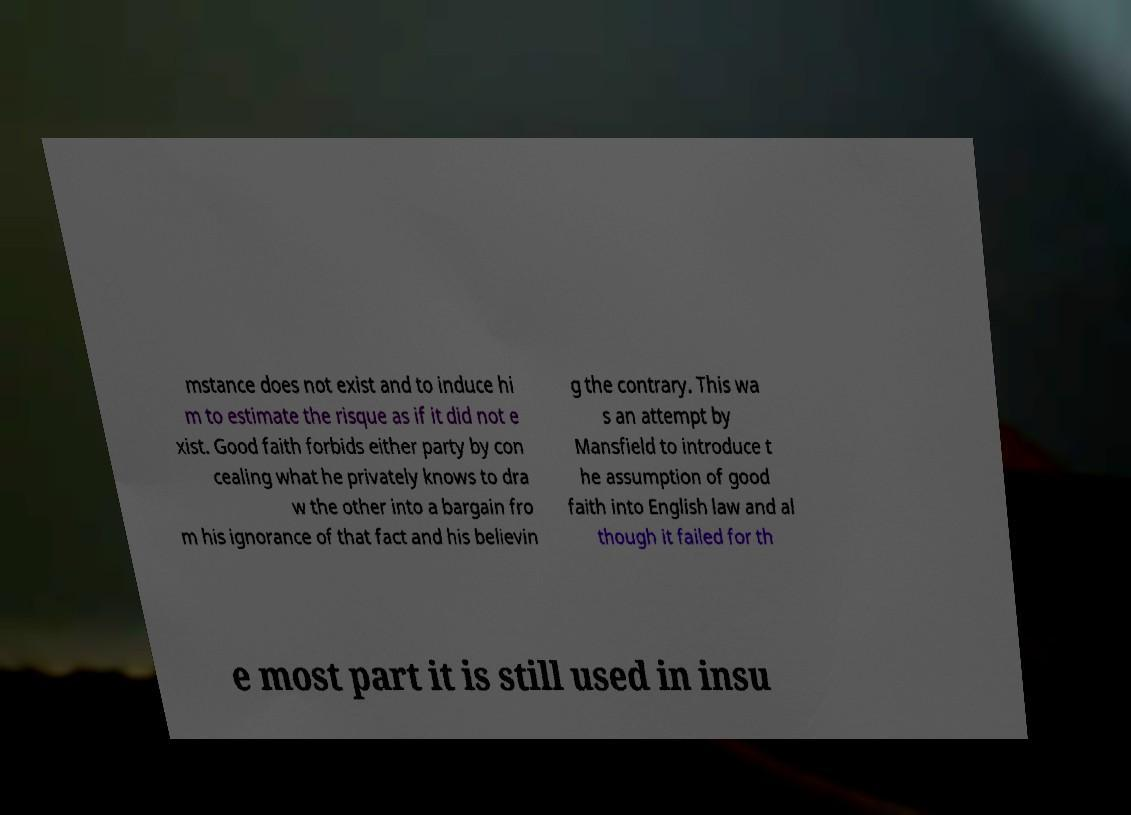I need the written content from this picture converted into text. Can you do that? mstance does not exist and to induce hi m to estimate the risque as if it did not e xist. Good faith forbids either party by con cealing what he privately knows to dra w the other into a bargain fro m his ignorance of that fact and his believin g the contrary. This wa s an attempt by Mansfield to introduce t he assumption of good faith into English law and al though it failed for th e most part it is still used in insu 